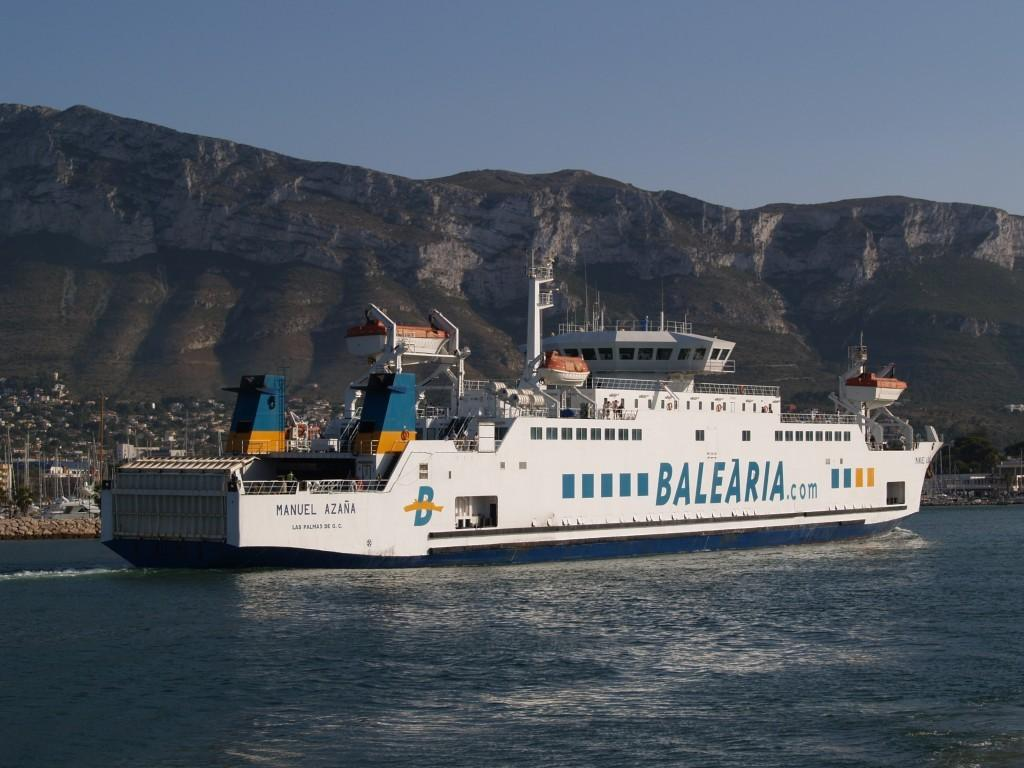What is the main subject of the image? There is a ship in the water. What can be seen in the background of the image? There are buildings, mountains, and the sky visible in the background. What type of pets can be seen on the stage in the image? There is no stage present in the image, and therefore no pets can be seen on a stage. 